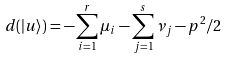<formula> <loc_0><loc_0><loc_500><loc_500>d ( | u \rangle ) = - \sum _ { i = 1 } ^ { r } \mu _ { i } - \sum _ { j = 1 } ^ { s } \nu _ { j } - p ^ { 2 } / 2</formula> 